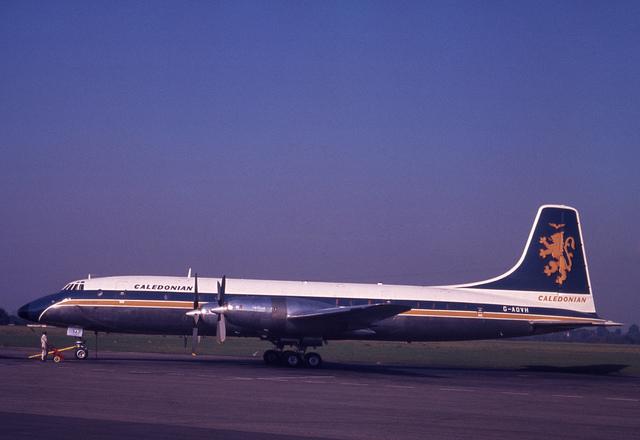Is this a cargo plane?
Write a very short answer. No. How long is the airplane?
Write a very short answer. Very. Where is this plane flying to?
Keep it brief. Caledonia. Where is this plane going?
Concise answer only. Nowhere. Is the photo colored?
Keep it brief. Yes. Is this an old airplane?
Quick response, please. No. What animal is on the logo of this plane?
Give a very brief answer. Lion. Overcast or sunny?
Be succinct. Sunny. 